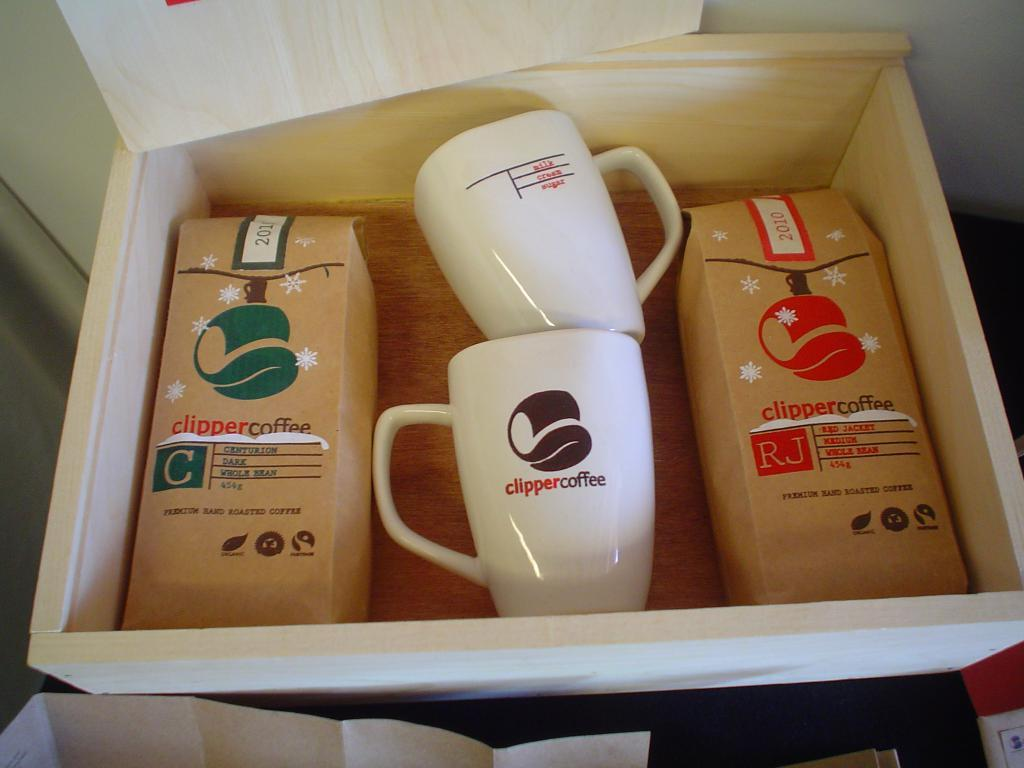<image>
Present a compact description of the photo's key features. Cups with the name Clipper Coffee on it inside of a box. 